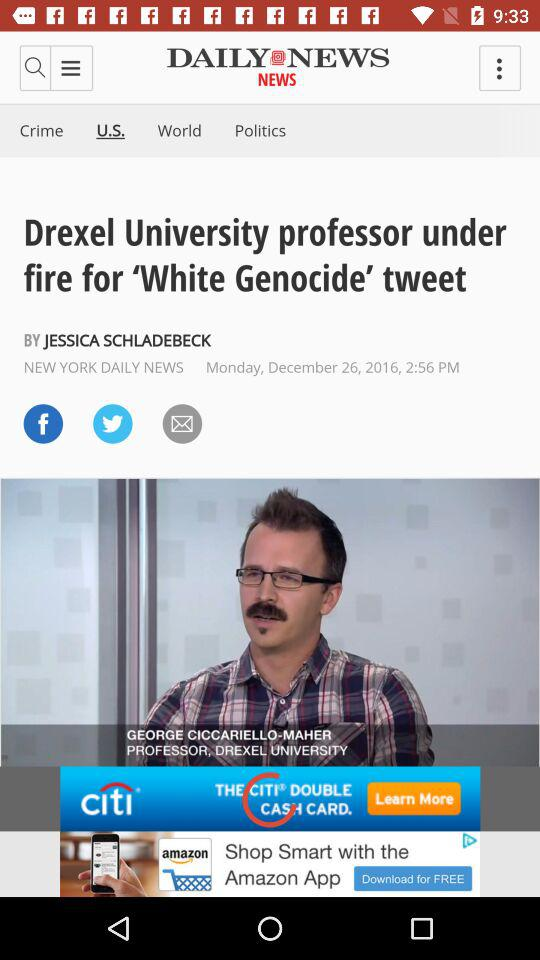What is the name of the newspaper that published news about "Drexel University"? The name of the newspaper that published news about "Drexel University" is "DAILY NEWS". 